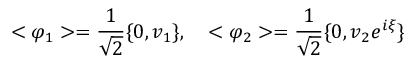<formula> <loc_0><loc_0><loc_500><loc_500>< \varphi _ { 1 } > = \frac { 1 } { \sqrt { 2 } } \{ 0 , v _ { 1 } \} , \quad < \varphi _ { 2 } > = \frac { 1 } { \sqrt { 2 } } \{ 0 , v _ { 2 } e ^ { i \xi } \}</formula> 